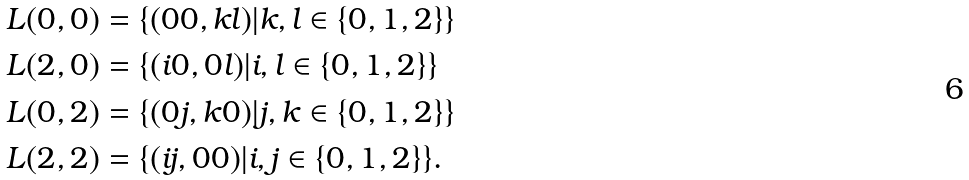Convert formula to latex. <formula><loc_0><loc_0><loc_500><loc_500>L ( 0 , 0 ) & = \{ ( 0 0 , k l ) | k , l \in \{ 0 , 1 , 2 \} \} \\ L ( 2 , 0 ) & = \{ ( i 0 , 0 l ) | i , l \in \{ 0 , 1 , 2 \} \} \\ L ( 0 , 2 ) & = \{ ( 0 j , k 0 ) | j , k \in \{ 0 , 1 , 2 \} \} \\ L ( 2 , 2 ) & = \{ ( i j , 0 0 ) | i , j \in \{ 0 , 1 , 2 \} \} .</formula> 